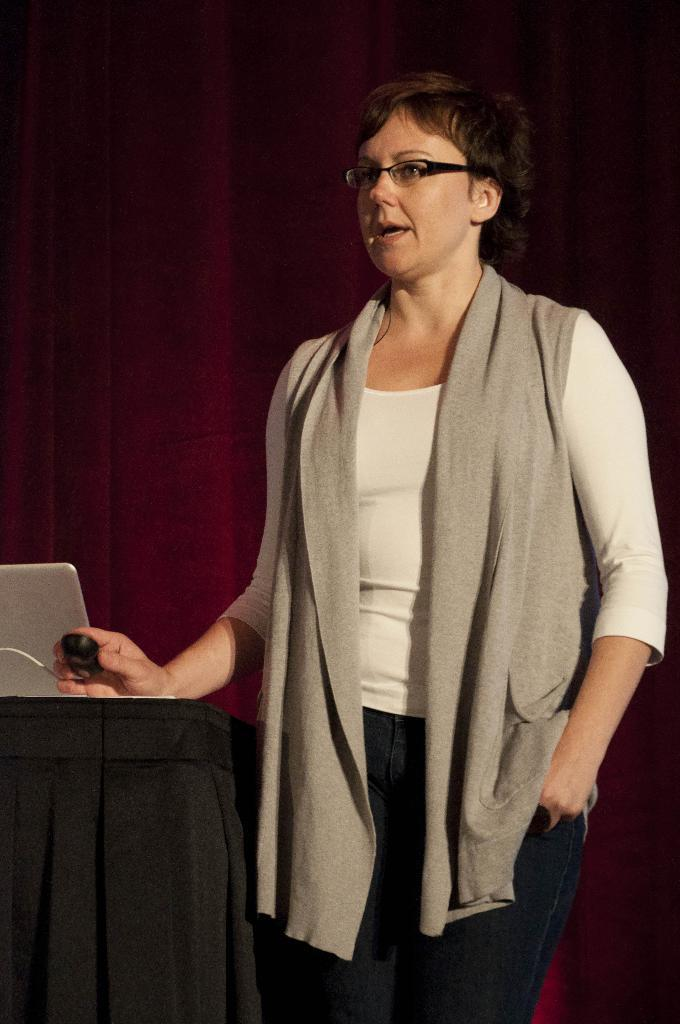What is the main subject of the image? There is a woman in the image. What is the woman doing in the image? The woman is standing in the image. What is the woman holding in the image? The woman is holding something in the image. What can be seen on the left side of the image? There is a table on the left side of the image. What is on the table in the image? There is a laptop and a cloth on the table in the image. What is the woman wearing in the image? The woman is wearing spectacles in the image. What type of donkey can be seen in the image? There is no donkey present in the image. What belief does the woman hold while standing in the image? The image does not provide any information about the woman's beliefs. 